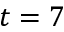<formula> <loc_0><loc_0><loc_500><loc_500>t = 7</formula> 